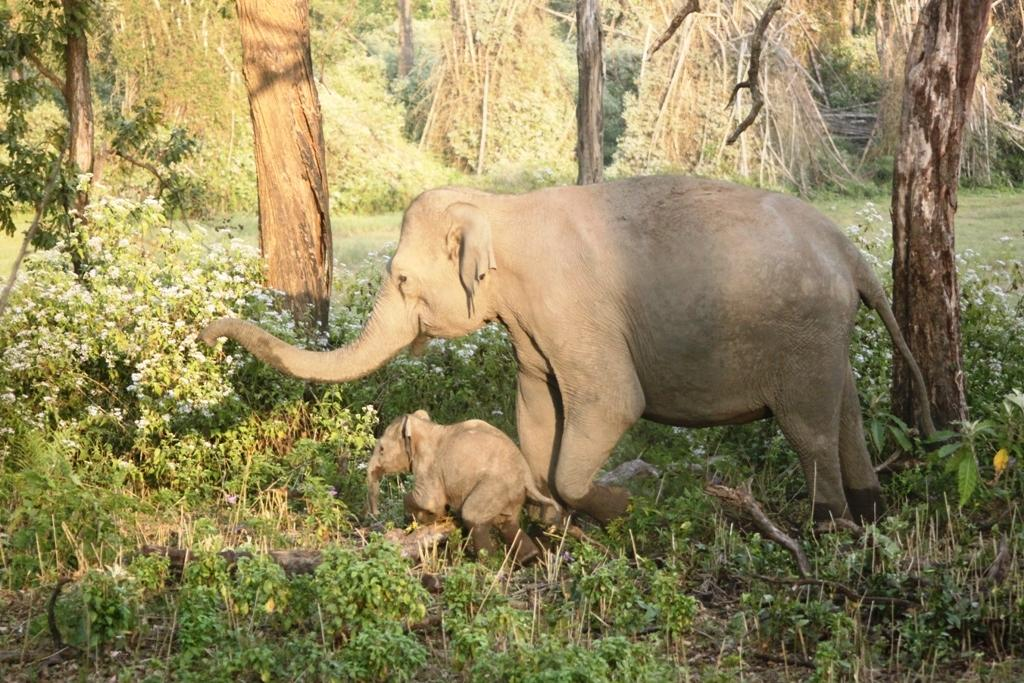What type of animal can be seen in the image? There is an elephant in the image. Is there a baby elephant in the image? Yes, there is a calf in the image. Where are the elephant and calf located in the image? Both the elephant and calf are on the ground. What can be seen in the background of the image? There are trees, grass, and plants in the background of the image. What type of art is displayed on the elephant's body in the image? There is no art displayed on the elephant's body in the image; it is a natural scene with an elephant and a calf. 